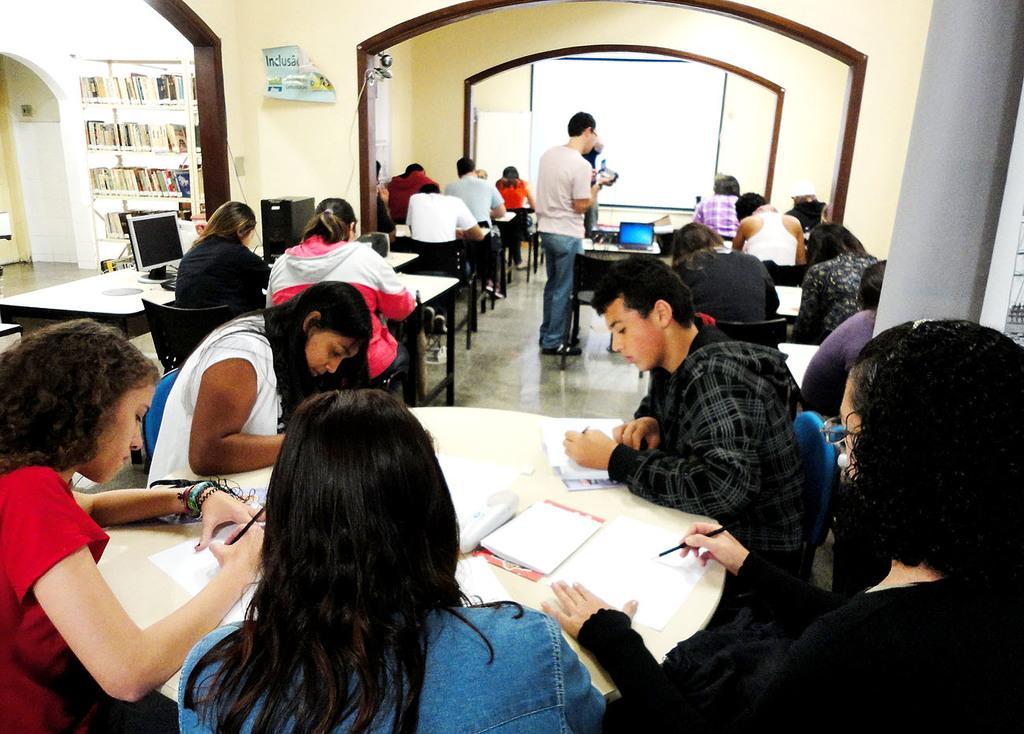How would you summarize this image in a sentence or two? In this picture there are people those who are sitting around the tables in the image, it seems to be they are writing and there is a book shelf on the left side of the image and there is a monitor and a laptop on the table. 